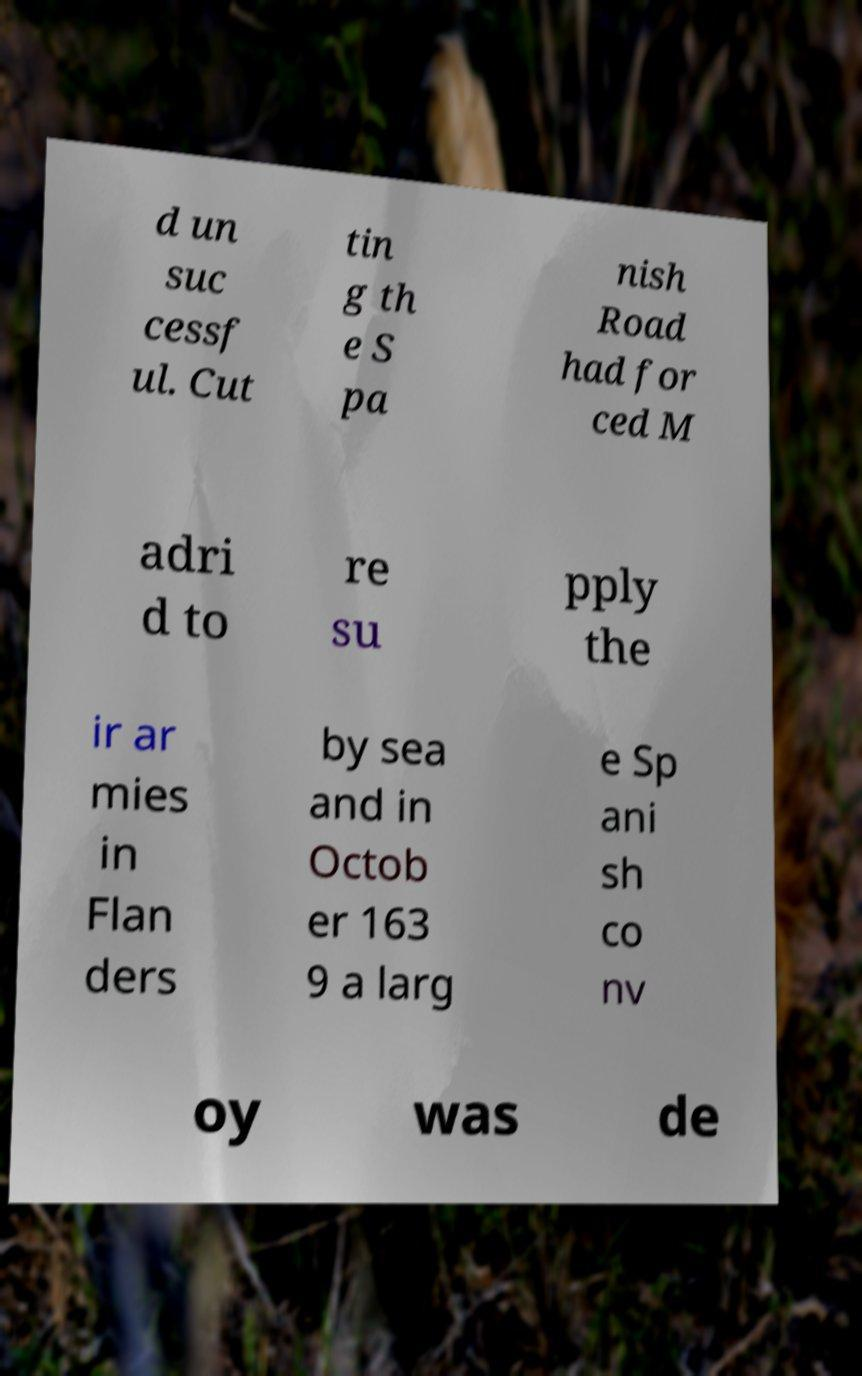What messages or text are displayed in this image? I need them in a readable, typed format. d un suc cessf ul. Cut tin g th e S pa nish Road had for ced M adri d to re su pply the ir ar mies in Flan ders by sea and in Octob er 163 9 a larg e Sp ani sh co nv oy was de 